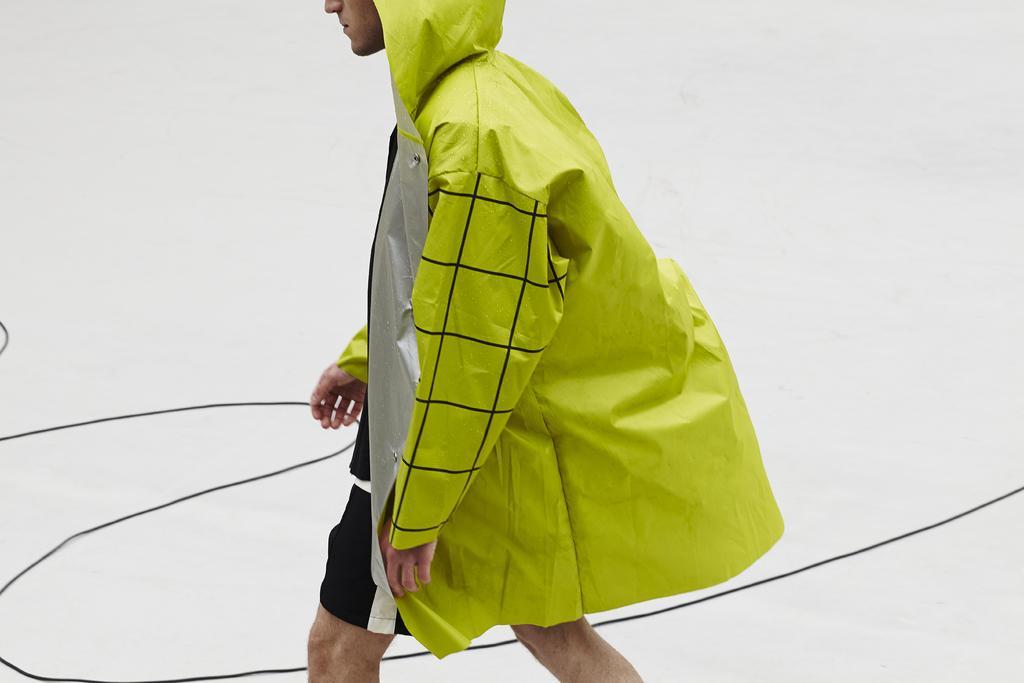Please provide a concise description of this image. In this image we can see a person walking by wearing a raincoat. 